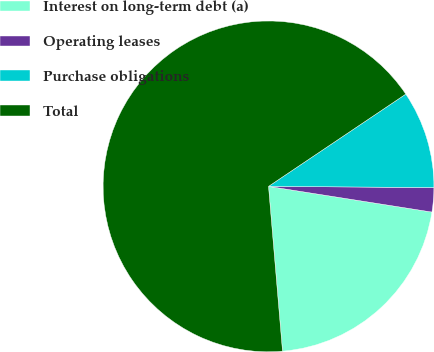<chart> <loc_0><loc_0><loc_500><loc_500><pie_chart><fcel>Interest on long-term debt (a)<fcel>Operating leases<fcel>Purchase obligations<fcel>Total<nl><fcel>21.17%<fcel>2.37%<fcel>9.53%<fcel>66.92%<nl></chart> 